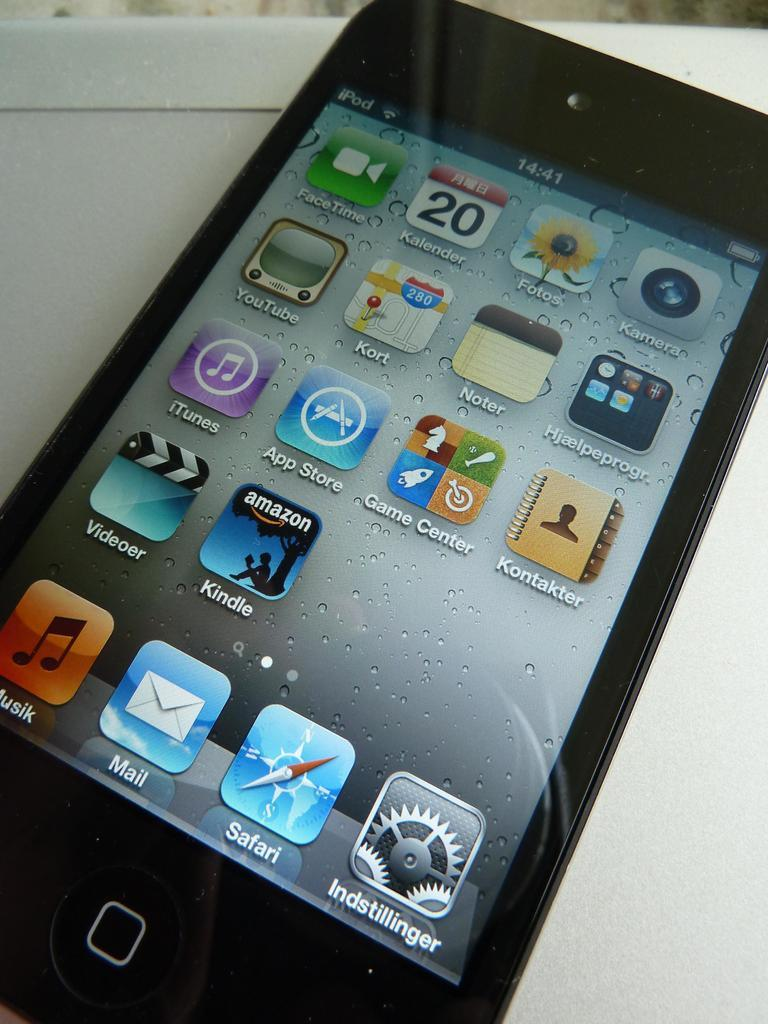<image>
Render a clear and concise summary of the photo. An iphone that is unlocked with a safari app on the bottom. 